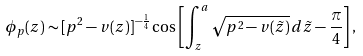<formula> <loc_0><loc_0><loc_500><loc_500>\phi _ { p } ( z ) \sim [ p ^ { 2 } - v ( z ) ] ^ { - \frac { 1 } { 4 } } \cos \left [ \int _ { z } ^ { a } \sqrt { p ^ { 2 } - v ( \tilde { z } ) } \, d \tilde { z } - \frac { \pi } { 4 } \right ] ,</formula> 